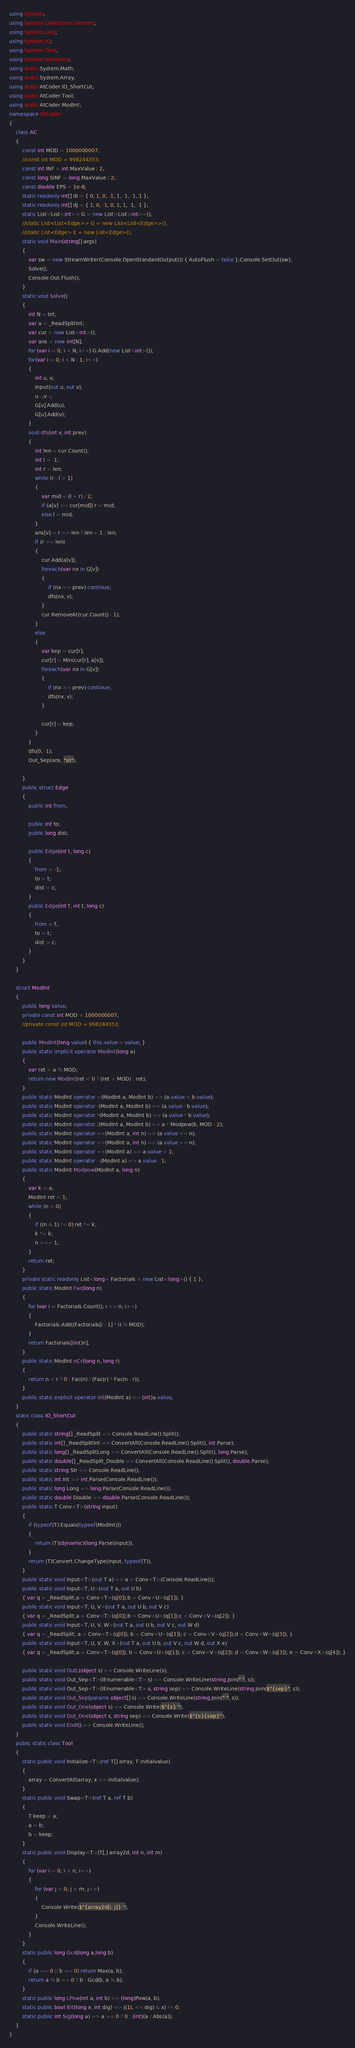<code> <loc_0><loc_0><loc_500><loc_500><_C#_>using System;
using System.Collections.Generic;
using System.Linq;
using System.IO;
using System.Text;
using System.Numerics;
using static System.Math;
using static System.Array;
using static AtCoder.IO_ShortCut;
using static AtCoder.Tool;
using static AtCoder.ModInt;
namespace AtCoder
{
    class AC
    {
        const int MOD = 1000000007;
        //const int MOD = 998244353;
        const int INF = int.MaxValue / 2;
        const long SINF = long.MaxValue / 2;
        const double EPS = 1e-8;
        static readonly int[] dI = { 0, 1, 0, -1, 1, -1, -1, 1 };
        static readonly int[] dJ = { 1, 0, -1, 0, 1, 1, -1, -1 };
        static List<List<int>> G = new List<List<int>>();
        //static List<List<Edge>> G = new List<List<Edge>>();
        //static List<Edge> E = new List<Edge>();
        static void Main(string[] args)
        {
            var sw = new StreamWriter(Console.OpenStandardOutput()) { AutoFlush = false };Console.SetOut(sw);
            Solve();
            Console.Out.Flush();
        }
        static void Solve()
        {
            int N = Int;
            var a = _ReadSplitInt;
            var cur = new List<int>();
            var ans = new int[N];
            for (var i = 0; i < N; i++) G.Add(new List<int>());
            for(var i = 0; i < N - 1; i++)
            {
                int u, v;
                Input(out u, out v);
                u--;v--;
                G[v].Add(u);
                G[u].Add(v);
            }
            void dfs(int v, int prev)
            {
                int len = cur.Count();
                int l = -1;
                int r = len;
                while (r - l > 1)
                {
                    var mid = (l + r) / 2;
                    if (a[v] <= cur[mid]) r = mid;
                    else l = mid;
                }
                ans[v] = r == len ? len + 1 : len;
                if (r == len)
                {
                    cur.Add(a[v]);
                    foreach(var nx in G[v])
                    {
                        if (nx == prev) continue;
                        dfs(nx, v);
                    }
                    cur.RemoveAt(cur.Count() - 1);
                }
                else
                {
                    var kep = cur[r];
                    cur[r] = Min(cur[r], a[v]);
                    foreach(var nx in G[v])
                    {
                        if (nx == prev) continue;
                        dfs(nx, v);
                    }

                    cur[r] = kep;
                }
            }
            dfs(0, -1);
            Out_Sep(ans, "\n");
                
        }
        public struct Edge
        {
            public int from;

            public int to;
            public long dist;
            
            public Edge(int t, long c)
            {
                from = -1;
                to = t;
                dist = c;
            }
            public Edge(int f, int t, long c)
            {
                from = f;
                to = t;
                dist = c;
            }
        }
    }
    
    struct ModInt
    {
        public long value;
        private const int MOD = 1000000007;
        //private const int MOD = 998244353;

        public ModInt(long value) { this.value = value; }
        public static implicit operator ModInt(long a)
        {
            var ret = a % MOD;
            return new ModInt(ret < 0 ? (ret + MOD) : ret);
        }
        public static ModInt operator +(ModInt a, ModInt b) => (a.value + b.value);
        public static ModInt operator -(ModInt a, ModInt b) => (a.value - b.value);
        public static ModInt operator *(ModInt a, ModInt b) => (a.value * b.value);
        public static ModInt operator /(ModInt a, ModInt b) => a * Modpow(b, MOD - 2);
        public static ModInt operator <<(ModInt a, int n) => (a.value << n);
        public static ModInt operator >>(ModInt a, int n) => (a.value >> n);
        public static ModInt operator ++(ModInt a) => a.value + 1;
        public static ModInt operator --(ModInt a) => a.value - 1;
        public static ModInt Modpow(ModInt a, long n)
        {
            var k = a;
            ModInt ret = 1;
            while (n > 0)
            {
                if ((n & 1) != 0) ret *= k;
                k *= k;
                n >>= 1;
            }
            return ret;
        }
        private static readonly List<long> Factorials = new List<long>() { 1 };
        public static ModInt Fac(long n)
        {
            for (var i = Factorials.Count(); i <= n; i++)
            {
                Factorials.Add((Factorials[i - 1] * i) % MOD);
            }
            return Factorials[(int)n];
        }
        public static ModInt nCr(long n, long r)
        {
            return n < r ? 0 : Fac(n) / (Fac(r) * Fac(n - r));
        }
        public static explicit operator int(ModInt a) => (int)a.value;
    }
    static class IO_ShortCut
    {
        public static string[] _ReadSplit => Console.ReadLine().Split();
        public static int[] _ReadSplitInt => ConvertAll(Console.ReadLine().Split(), int.Parse);
        public static long[] _ReadSplitLong => ConvertAll(Console.ReadLine().Split(), long.Parse);
        public static double[] _ReadSplit_Double => ConvertAll(Console.ReadLine().Split(), double.Parse);
        public static string Str => Console.ReadLine();
        public static int Int => int.Parse(Console.ReadLine());
        public static long Long => long.Parse(Console.ReadLine());
        public static double Double => double.Parse(Console.ReadLine());
        public static T Conv<T>(string input)
        {
            if (typeof(T).Equals(typeof(ModInt)))
            {
                return (T)(dynamic)(long.Parse(input));
            }
            return (T)Convert.ChangeType(input, typeof(T));
        }
        public static void Input<T>(out T a) => a = Conv<T>(Console.ReadLine());
        public static void Input<T, U>(out T a, out U b)
        { var q = _ReadSplit;a = Conv<T>(q[0]);b = Conv<U>(q[1]); }
        public static void Input<T, U, V>(out T a, out U b, out V c)
        { var q = _ReadSplit;a = Conv<T>(q[0]);b = Conv<U>(q[1]);c = Conv<V>(q[2]); }
        public static void Input<T, U, V, W>(out T a, out U b, out V c, out W d)
        { var q = _ReadSplit; a = Conv<T>(q[0]); b = Conv<U>(q[1]); c = Conv<V>(q[2]);d = Conv<W>(q[3]); }
        public static void Input<T, U, V, W, X>(out T a, out U b, out V c, out W d, out X e)
        { var q = _ReadSplit;a = Conv<T>(q[0]); b = Conv<U>(q[1]); c = Conv<V>(q[2]); d = Conv<W>(q[3]); e = Conv<X>(q[4]); }

        public static void OutL(object s) => Console.WriteLine(s);
        public static void Out_Sep<T>(IEnumerable<T> s) => Console.WriteLine(string.Join(" ", s));
        public static void Out_Sep<T>(IEnumerable<T> s, string sep) => Console.WriteLine(string.Join($"{sep}", s));
        public static void Out_Sep(params object[] s) => Console.WriteLine(string.Join(" ", s));
        public static void Out_One(object s) => Console.Write($"{s} ");
        public static void Out_One(object s, string sep) => Console.Write($"{s}{sep}");
        public static void Endl() => Console.WriteLine();
    }
    public static class Tool
    {
        static public void Initialize<T>(ref T[] array, T initialvalue)
        {
            array = ConvertAll(array, x => initialvalue);
        }
        static public void Swap<T>(ref T a, ref T b)
        {
            T keep = a;
            a = b;
            b = keep;
        }
        static public void Display<T>(T[,] array2d, int n, int m)
        {
            for (var i = 0; i < n; i++)
            {
                for (var j = 0; j < m; j++)
                {
                    Console.Write($"{array2d[i, j]} ");
                }
                Console.WriteLine();
            }
        }
        static public long Gcd(long a,long b)
        {
            if (a == 0 || b == 0) return Max(a, b);
            return a % b == 0 ? b : Gcd(b, a % b);
        }
        static public long LPow(int a, int b) => (long)Pow(a, b);
        static public bool Bit(long x, int dig) => ((1L << dig) & x) != 0;
        static public int Sig(long a) => a == 0 ? 0 : (int)(a / Abs(a));
    }
}</code> 